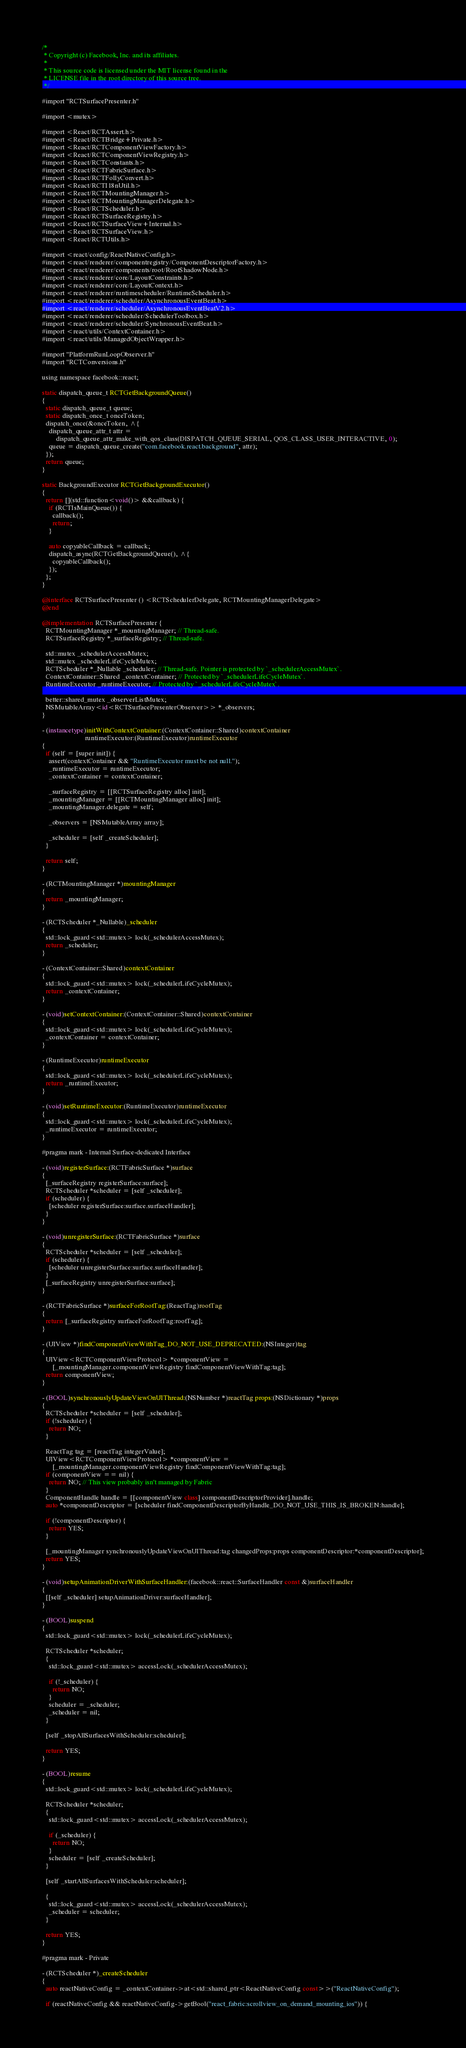Convert code to text. <code><loc_0><loc_0><loc_500><loc_500><_ObjectiveC_>/*
 * Copyright (c) Facebook, Inc. and its affiliates.
 *
 * This source code is licensed under the MIT license found in the
 * LICENSE file in the root directory of this source tree.
 */

#import "RCTSurfacePresenter.h"

#import <mutex>

#import <React/RCTAssert.h>
#import <React/RCTBridge+Private.h>
#import <React/RCTComponentViewFactory.h>
#import <React/RCTComponentViewRegistry.h>
#import <React/RCTConstants.h>
#import <React/RCTFabricSurface.h>
#import <React/RCTFollyConvert.h>
#import <React/RCTI18nUtil.h>
#import <React/RCTMountingManager.h>
#import <React/RCTMountingManagerDelegate.h>
#import <React/RCTScheduler.h>
#import <React/RCTSurfaceRegistry.h>
#import <React/RCTSurfaceView+Internal.h>
#import <React/RCTSurfaceView.h>
#import <React/RCTUtils.h>

#import <react/config/ReactNativeConfig.h>
#import <react/renderer/componentregistry/ComponentDescriptorFactory.h>
#import <react/renderer/components/root/RootShadowNode.h>
#import <react/renderer/core/LayoutConstraints.h>
#import <react/renderer/core/LayoutContext.h>
#import <react/renderer/runtimescheduler/RuntimeScheduler.h>
#import <react/renderer/scheduler/AsynchronousEventBeat.h>
#import <react/renderer/scheduler/AsynchronousEventBeatV2.h>
#import <react/renderer/scheduler/SchedulerToolbox.h>
#import <react/renderer/scheduler/SynchronousEventBeat.h>
#import <react/utils/ContextContainer.h>
#import <react/utils/ManagedObjectWrapper.h>

#import "PlatformRunLoopObserver.h"
#import "RCTConversions.h"

using namespace facebook::react;

static dispatch_queue_t RCTGetBackgroundQueue()
{
  static dispatch_queue_t queue;
  static dispatch_once_t onceToken;
  dispatch_once(&onceToken, ^{
    dispatch_queue_attr_t attr =
        dispatch_queue_attr_make_with_qos_class(DISPATCH_QUEUE_SERIAL, QOS_CLASS_USER_INTERACTIVE, 0);
    queue = dispatch_queue_create("com.facebook.react.background", attr);
  });
  return queue;
}

static BackgroundExecutor RCTGetBackgroundExecutor()
{
  return [](std::function<void()> &&callback) {
    if (RCTIsMainQueue()) {
      callback();
      return;
    }

    auto copyableCallback = callback;
    dispatch_async(RCTGetBackgroundQueue(), ^{
      copyableCallback();
    });
  };
}

@interface RCTSurfacePresenter () <RCTSchedulerDelegate, RCTMountingManagerDelegate>
@end

@implementation RCTSurfacePresenter {
  RCTMountingManager *_mountingManager; // Thread-safe.
  RCTSurfaceRegistry *_surfaceRegistry; // Thread-safe.

  std::mutex _schedulerAccessMutex;
  std::mutex _schedulerLifeCycleMutex;
  RCTScheduler *_Nullable _scheduler; // Thread-safe. Pointer is protected by `_schedulerAccessMutex`.
  ContextContainer::Shared _contextContainer; // Protected by `_schedulerLifeCycleMutex`.
  RuntimeExecutor _runtimeExecutor; // Protected by `_schedulerLifeCycleMutex`.

  better::shared_mutex _observerListMutex;
  NSMutableArray<id<RCTSurfacePresenterObserver>> *_observers;
}

- (instancetype)initWithContextContainer:(ContextContainer::Shared)contextContainer
                         runtimeExecutor:(RuntimeExecutor)runtimeExecutor
{
  if (self = [super init]) {
    assert(contextContainer && "RuntimeExecutor must be not null.");
    _runtimeExecutor = runtimeExecutor;
    _contextContainer = contextContainer;

    _surfaceRegistry = [[RCTSurfaceRegistry alloc] init];
    _mountingManager = [[RCTMountingManager alloc] init];
    _mountingManager.delegate = self;

    _observers = [NSMutableArray array];

    _scheduler = [self _createScheduler];
  }

  return self;
}

- (RCTMountingManager *)mountingManager
{
  return _mountingManager;
}

- (RCTScheduler *_Nullable)_scheduler
{
  std::lock_guard<std::mutex> lock(_schedulerAccessMutex);
  return _scheduler;
}

- (ContextContainer::Shared)contextContainer
{
  std::lock_guard<std::mutex> lock(_schedulerLifeCycleMutex);
  return _contextContainer;
}

- (void)setContextContainer:(ContextContainer::Shared)contextContainer
{
  std::lock_guard<std::mutex> lock(_schedulerLifeCycleMutex);
  _contextContainer = contextContainer;
}

- (RuntimeExecutor)runtimeExecutor
{
  std::lock_guard<std::mutex> lock(_schedulerLifeCycleMutex);
  return _runtimeExecutor;
}

- (void)setRuntimeExecutor:(RuntimeExecutor)runtimeExecutor
{
  std::lock_guard<std::mutex> lock(_schedulerLifeCycleMutex);
  _runtimeExecutor = runtimeExecutor;
}

#pragma mark - Internal Surface-dedicated Interface

- (void)registerSurface:(RCTFabricSurface *)surface
{
  [_surfaceRegistry registerSurface:surface];
  RCTScheduler *scheduler = [self _scheduler];
  if (scheduler) {
    [scheduler registerSurface:surface.surfaceHandler];
  }
}

- (void)unregisterSurface:(RCTFabricSurface *)surface
{
  RCTScheduler *scheduler = [self _scheduler];
  if (scheduler) {
    [scheduler unregisterSurface:surface.surfaceHandler];
  }
  [_surfaceRegistry unregisterSurface:surface];
}

- (RCTFabricSurface *)surfaceForRootTag:(ReactTag)rootTag
{
  return [_surfaceRegistry surfaceForRootTag:rootTag];
}

- (UIView *)findComponentViewWithTag_DO_NOT_USE_DEPRECATED:(NSInteger)tag
{
  UIView<RCTComponentViewProtocol> *componentView =
      [_mountingManager.componentViewRegistry findComponentViewWithTag:tag];
  return componentView;
}

- (BOOL)synchronouslyUpdateViewOnUIThread:(NSNumber *)reactTag props:(NSDictionary *)props
{
  RCTScheduler *scheduler = [self _scheduler];
  if (!scheduler) {
    return NO;
  }

  ReactTag tag = [reactTag integerValue];
  UIView<RCTComponentViewProtocol> *componentView =
      [_mountingManager.componentViewRegistry findComponentViewWithTag:tag];
  if (componentView == nil) {
    return NO; // This view probably isn't managed by Fabric
  }
  ComponentHandle handle = [[componentView class] componentDescriptorProvider].handle;
  auto *componentDescriptor = [scheduler findComponentDescriptorByHandle_DO_NOT_USE_THIS_IS_BROKEN:handle];

  if (!componentDescriptor) {
    return YES;
  }

  [_mountingManager synchronouslyUpdateViewOnUIThread:tag changedProps:props componentDescriptor:*componentDescriptor];
  return YES;
}

- (void)setupAnimationDriverWithSurfaceHandler:(facebook::react::SurfaceHandler const &)surfaceHandler
{
  [[self _scheduler] setupAnimationDriver:surfaceHandler];
}

- (BOOL)suspend
{
  std::lock_guard<std::mutex> lock(_schedulerLifeCycleMutex);

  RCTScheduler *scheduler;
  {
    std::lock_guard<std::mutex> accessLock(_schedulerAccessMutex);

    if (!_scheduler) {
      return NO;
    }
    scheduler = _scheduler;
    _scheduler = nil;
  }

  [self _stopAllSurfacesWithScheduler:scheduler];

  return YES;
}

- (BOOL)resume
{
  std::lock_guard<std::mutex> lock(_schedulerLifeCycleMutex);

  RCTScheduler *scheduler;
  {
    std::lock_guard<std::mutex> accessLock(_schedulerAccessMutex);

    if (_scheduler) {
      return NO;
    }
    scheduler = [self _createScheduler];
  }

  [self _startAllSurfacesWithScheduler:scheduler];

  {
    std::lock_guard<std::mutex> accessLock(_schedulerAccessMutex);
    _scheduler = scheduler;
  }

  return YES;
}

#pragma mark - Private

- (RCTScheduler *)_createScheduler
{
  auto reactNativeConfig = _contextContainer->at<std::shared_ptr<ReactNativeConfig const>>("ReactNativeConfig");

  if (reactNativeConfig && reactNativeConfig->getBool("react_fabric:scrollview_on_demand_mounting_ios")) {</code> 